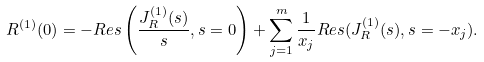Convert formula to latex. <formula><loc_0><loc_0><loc_500><loc_500>R ^ { ( 1 ) } ( 0 ) = - R e s \left ( \frac { J _ { R } ^ { ( 1 ) } ( s ) } { s } , s = 0 \right ) + \sum _ { j = 1 } ^ { m } \frac { 1 } { x _ { j } } R e s ( J _ { R } ^ { ( 1 ) } ( s ) , s = - x _ { j } ) .</formula> 